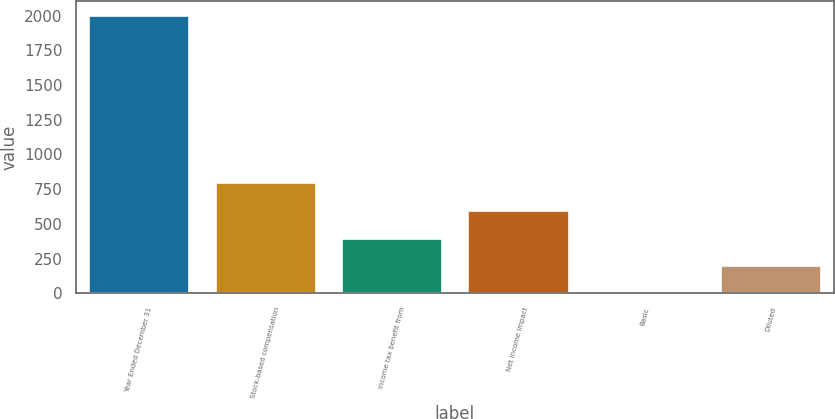Convert chart. <chart><loc_0><loc_0><loc_500><loc_500><bar_chart><fcel>Year Ended December 31<fcel>Stock-based compensation<fcel>Income tax benefit from<fcel>Net income impact<fcel>Basic<fcel>Diluted<nl><fcel>2006<fcel>802.43<fcel>401.23<fcel>601.83<fcel>0.03<fcel>200.63<nl></chart> 